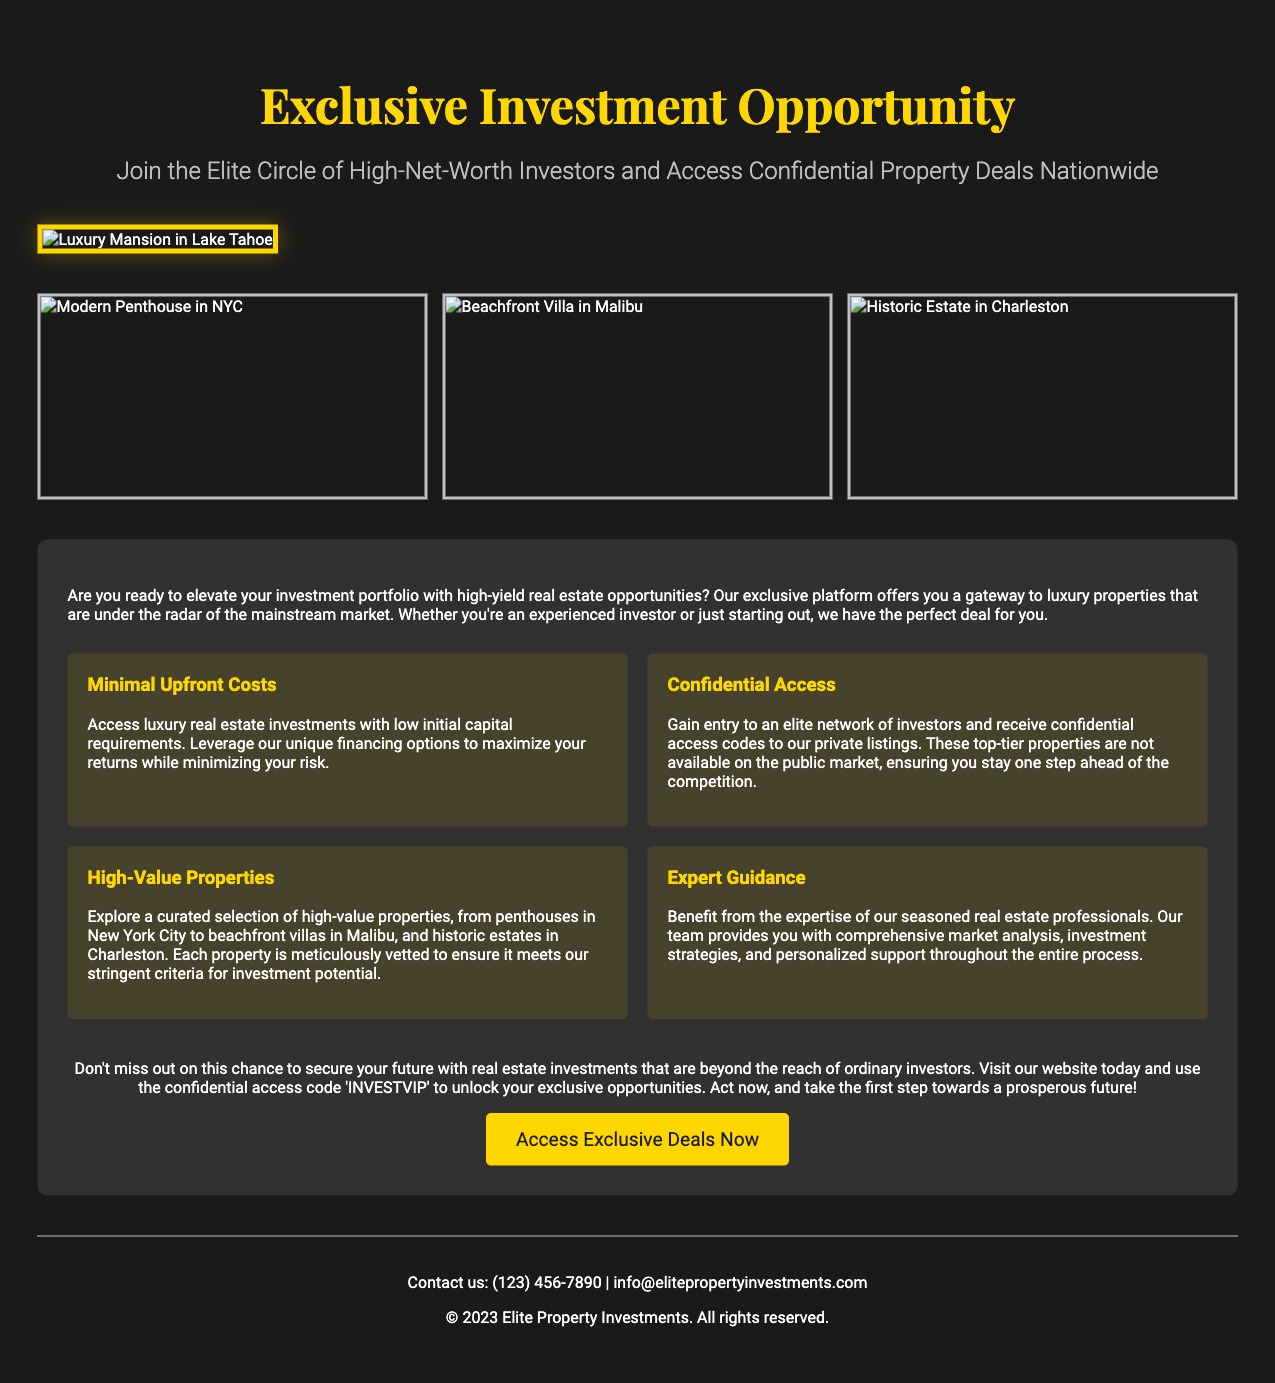What is the main title of the advertisement? The main title is prominently displayed at the top of the document, highlighting the investment opportunity.
Answer: Exclusive Investment Opportunity How many images are in the gallery? The gallery section features three images representing different properties.
Answer: 3 What is the confidential access code mentioned? The advertisement encourages readers to use a specific code for accessing exclusive content.
Answer: INVESTVIP What type of properties are highlighted in the document? The document mentions the nature of the investment properties available to potential investors.
Answer: Luxury properties Who does the advertisement target? The advertisement specifies its target audience in the subtitle, appealing to a particular group.
Answer: High-Net-Worth Investors What is one of the key advantages of the investment mentioned? The document outlines several key benefits, but one is highlighted prominently.
Answer: Minimal Upfront Costs What is the purpose of the CTA (Call to Action)? The CTA encourages readers to take immediate action regarding the investment opportunity presented.
Answer: Access Exclusive Deals Now What is the phone number provided for contact? The advertisement includes a specific phone number for potential inquiries from interested investors.
Answer: (123) 456-7890 What year is printed as part of the copyright in the footer? The footer includes a copyright statement that provides the year associated with the document's publication.
Answer: 2023 